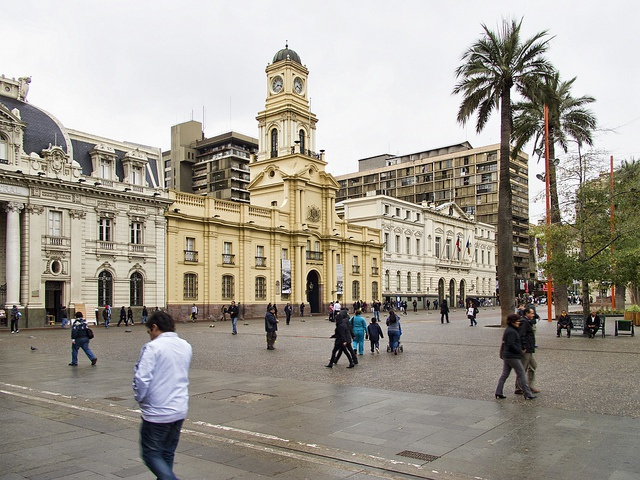Describe the objects in this image and their specific colors. I can see people in white, black, gray, and darkgray tones, people in white, lavender, black, and darkgray tones, people in white, black, gray, maroon, and darkgray tones, people in white, black, gray, navy, and darkblue tones, and people in white, black, gray, and maroon tones in this image. 